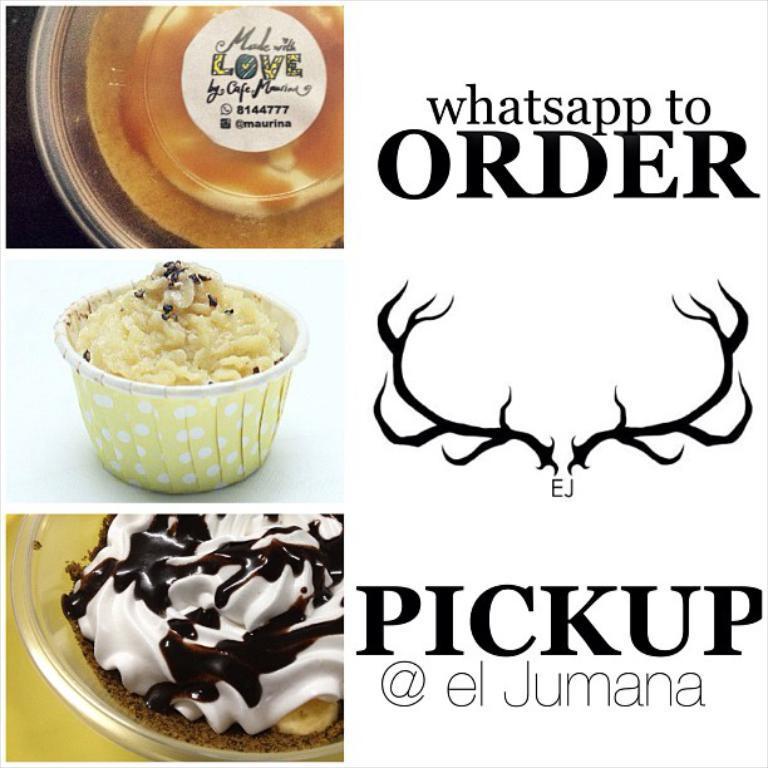Please provide a concise description of this image. In this image we can see a poster with something written. On that something is written. Also there is a logo. On the left side there are images of food items on bowls. 